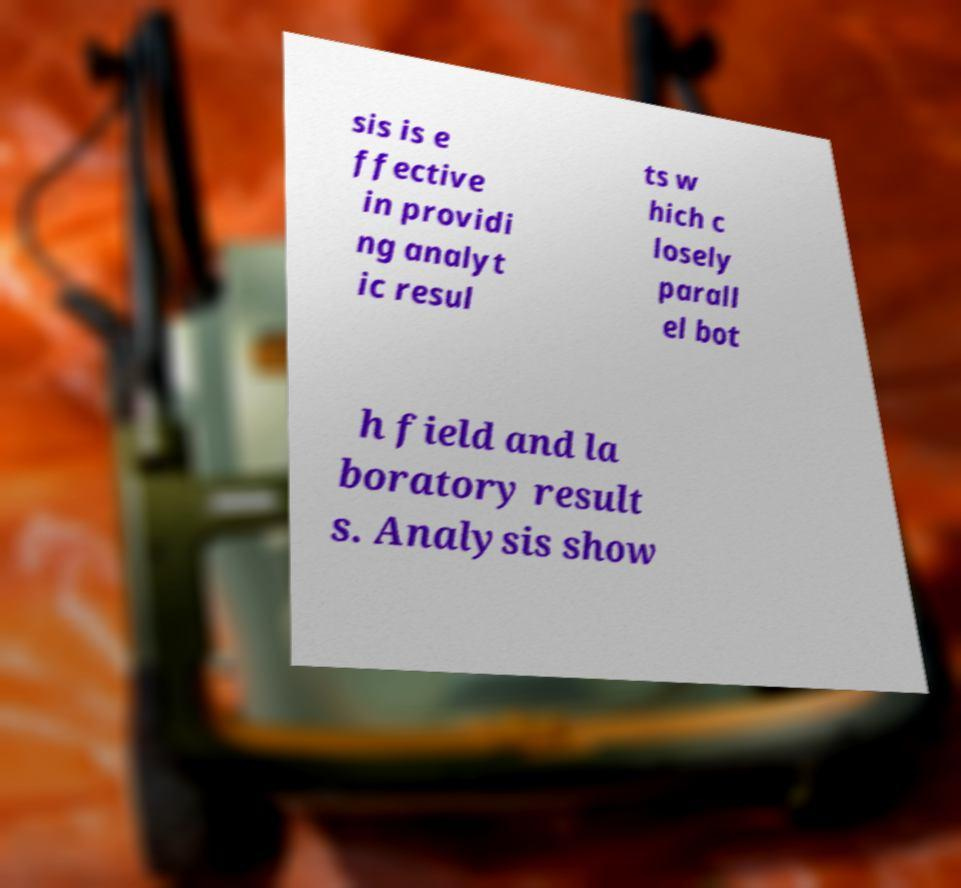Can you read and provide the text displayed in the image?This photo seems to have some interesting text. Can you extract and type it out for me? sis is e ffective in providi ng analyt ic resul ts w hich c losely parall el bot h field and la boratory result s. Analysis show 